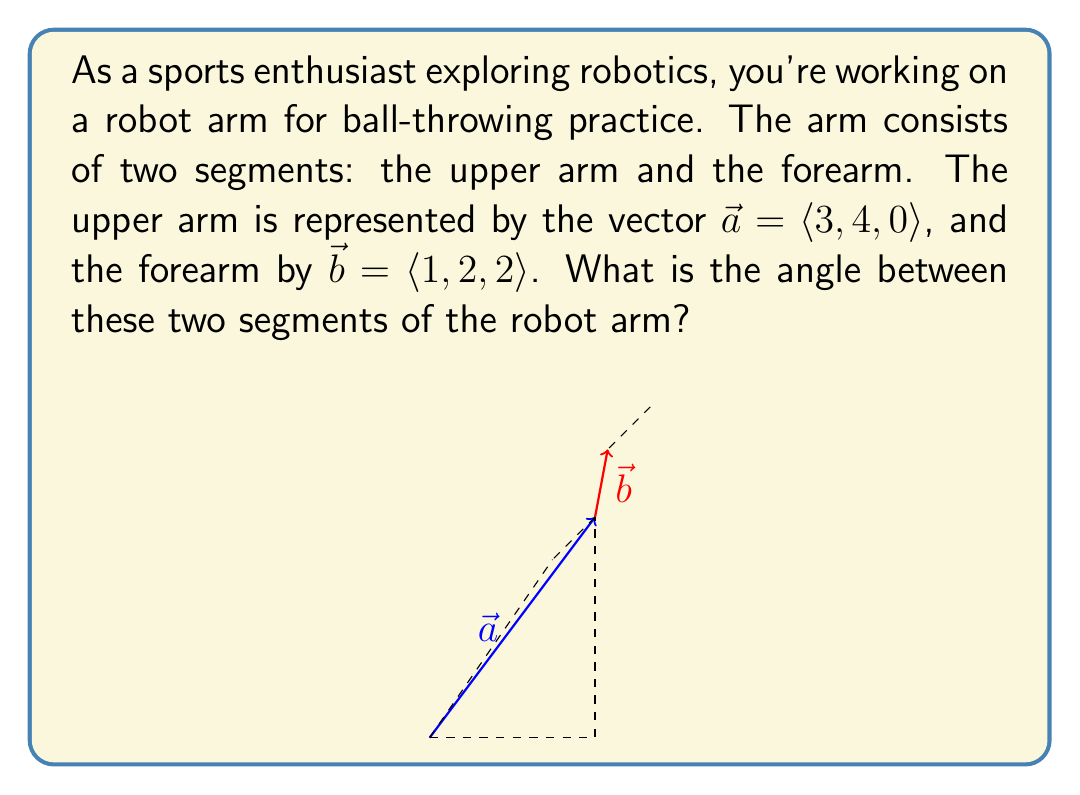Can you answer this question? To solve this problem, we'll use the dot product formula to find the angle between two vectors. The formula is:

$$\cos \theta = \frac{\vec{a} \cdot \vec{b}}{|\vec{a}||\vec{b}|}$$

Where $\theta$ is the angle between the vectors, $\vec{a} \cdot \vec{b}$ is the dot product, and $|\vec{a}|$ and $|\vec{b}|$ are the magnitudes of the vectors.

Step 1: Calculate the dot product $\vec{a} \cdot \vec{b}$
$$\vec{a} \cdot \vec{b} = (3)(1) + (4)(2) + (0)(2) = 3 + 8 + 0 = 11$$

Step 2: Calculate the magnitudes of $\vec{a}$ and $\vec{b}$
$$|\vec{a}| = \sqrt{3^2 + 4^2 + 0^2} = \sqrt{9 + 16 + 0} = \sqrt{25} = 5$$
$$|\vec{b}| = \sqrt{1^2 + 2^2 + 2^2} = \sqrt{1 + 4 + 4} = \sqrt{9} = 3$$

Step 3: Substitute into the formula
$$\cos \theta = \frac{11}{(5)(3)} = \frac{11}{15}$$

Step 4: Take the inverse cosine (arccos) of both sides
$$\theta = \arccos(\frac{11}{15})$$

Step 5: Calculate the result (rounded to two decimal places)
$$\theta \approx 0.89 \text{ radians}$$

To convert to degrees, multiply by $\frac{180}{\pi}$:
$$\theta \approx 0.89 \cdot \frac{180}{\pi} \approx 51.06°$$
Answer: The angle between the two segments of the robot arm is approximately 51.06°. 